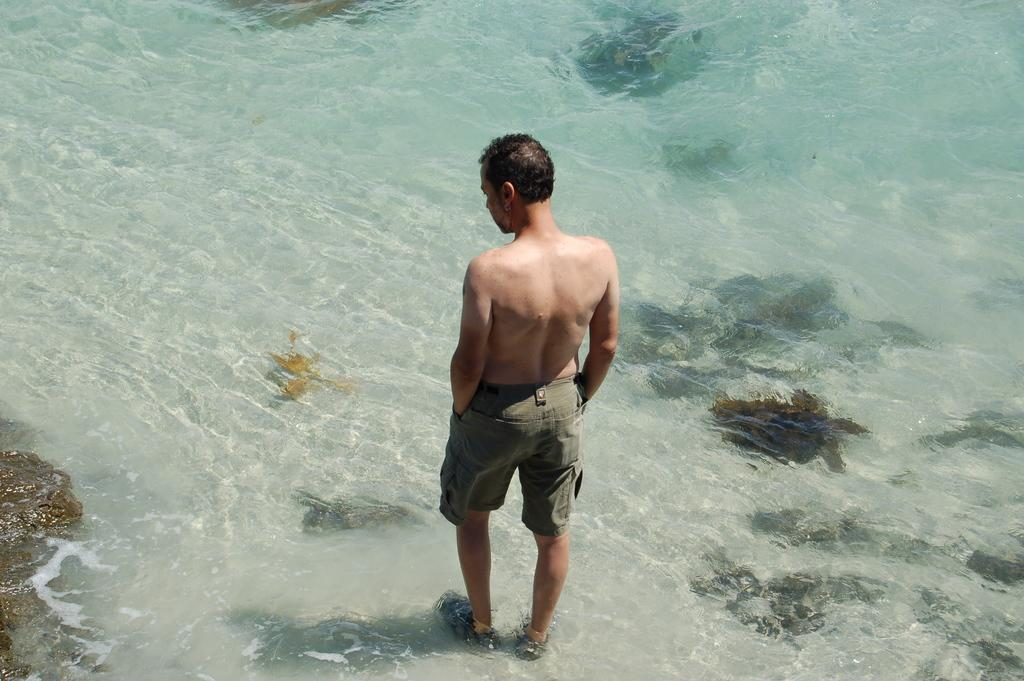What is the main subject of the image? There is a man standing in the image. What can be seen in the background of the image? There is water visible in the image. What type of creatures might be found in the water? Under the water, water animals are present. What advice does the man's dad give him in the image? There is no mention of the man's dad or any advice being given in the image. 